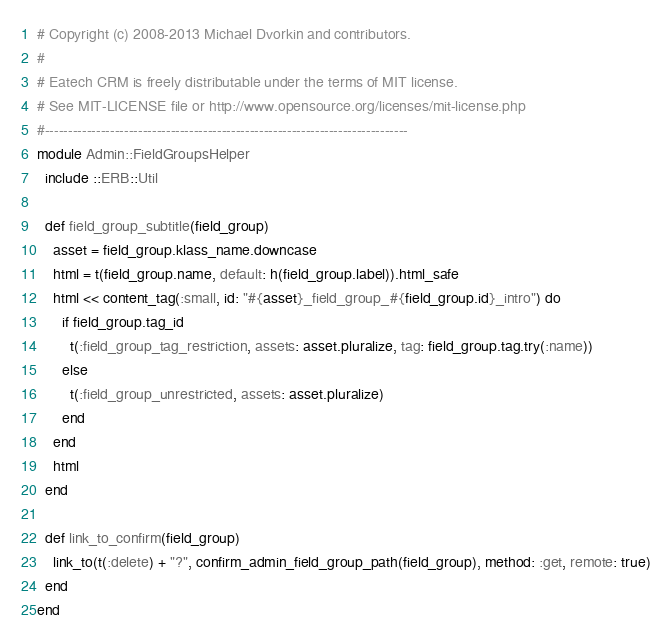Convert code to text. <code><loc_0><loc_0><loc_500><loc_500><_Ruby_># Copyright (c) 2008-2013 Michael Dvorkin and contributors.
#
# Eatech CRM is freely distributable under the terms of MIT license.
# See MIT-LICENSE file or http://www.opensource.org/licenses/mit-license.php
#------------------------------------------------------------------------------
module Admin::FieldGroupsHelper
  include ::ERB::Util

  def field_group_subtitle(field_group)
    asset = field_group.klass_name.downcase
    html = t(field_group.name, default: h(field_group.label)).html_safe
    html << content_tag(:small, id: "#{asset}_field_group_#{field_group.id}_intro") do
      if field_group.tag_id
        t(:field_group_tag_restriction, assets: asset.pluralize, tag: field_group.tag.try(:name))
      else
        t(:field_group_unrestricted, assets: asset.pluralize)
      end
    end
    html
  end

  def link_to_confirm(field_group)
    link_to(t(:delete) + "?", confirm_admin_field_group_path(field_group), method: :get, remote: true)
  end
end
</code> 